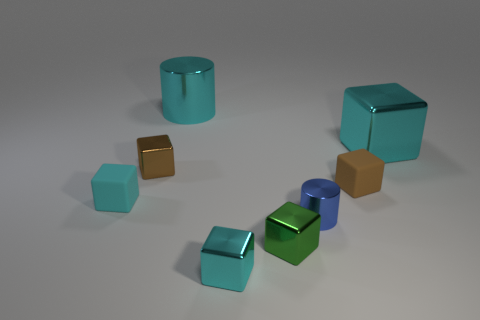Which objects in the image seem to reflect more light, and what does this tell us about their surface texture? The objects that reflect the most light are the teal-colored metal cubes. Their shiny surfaces indicate that they have smooth and polished textures which enhance reflectivity. 